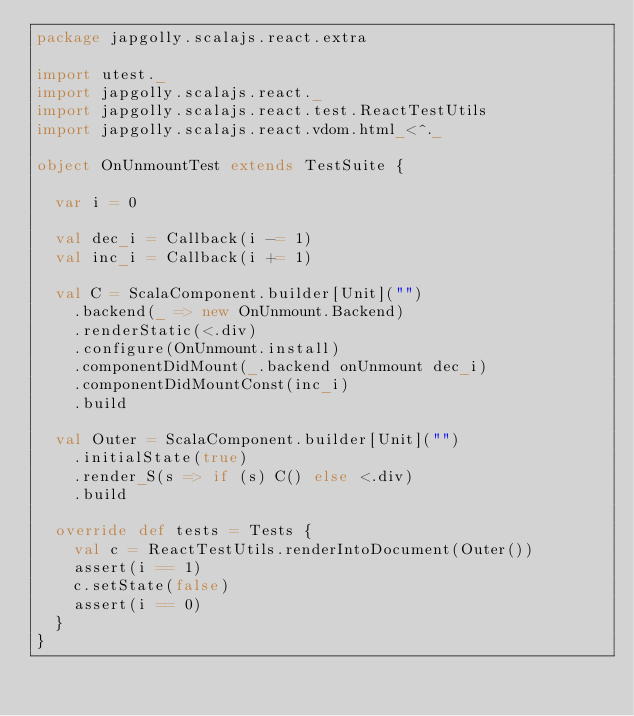<code> <loc_0><loc_0><loc_500><loc_500><_Scala_>package japgolly.scalajs.react.extra

import utest._
import japgolly.scalajs.react._
import japgolly.scalajs.react.test.ReactTestUtils
import japgolly.scalajs.react.vdom.html_<^._

object OnUnmountTest extends TestSuite {

  var i = 0

  val dec_i = Callback(i -= 1)
  val inc_i = Callback(i += 1)

  val C = ScalaComponent.builder[Unit]("")
    .backend(_ => new OnUnmount.Backend)
    .renderStatic(<.div)
    .configure(OnUnmount.install)
    .componentDidMount(_.backend onUnmount dec_i)
    .componentDidMountConst(inc_i)
    .build

  val Outer = ScalaComponent.builder[Unit]("")
    .initialState(true)
    .render_S(s => if (s) C() else <.div)
    .build

  override def tests = Tests {
    val c = ReactTestUtils.renderIntoDocument(Outer())
    assert(i == 1)
    c.setState(false)
    assert(i == 0)
  }
}
</code> 